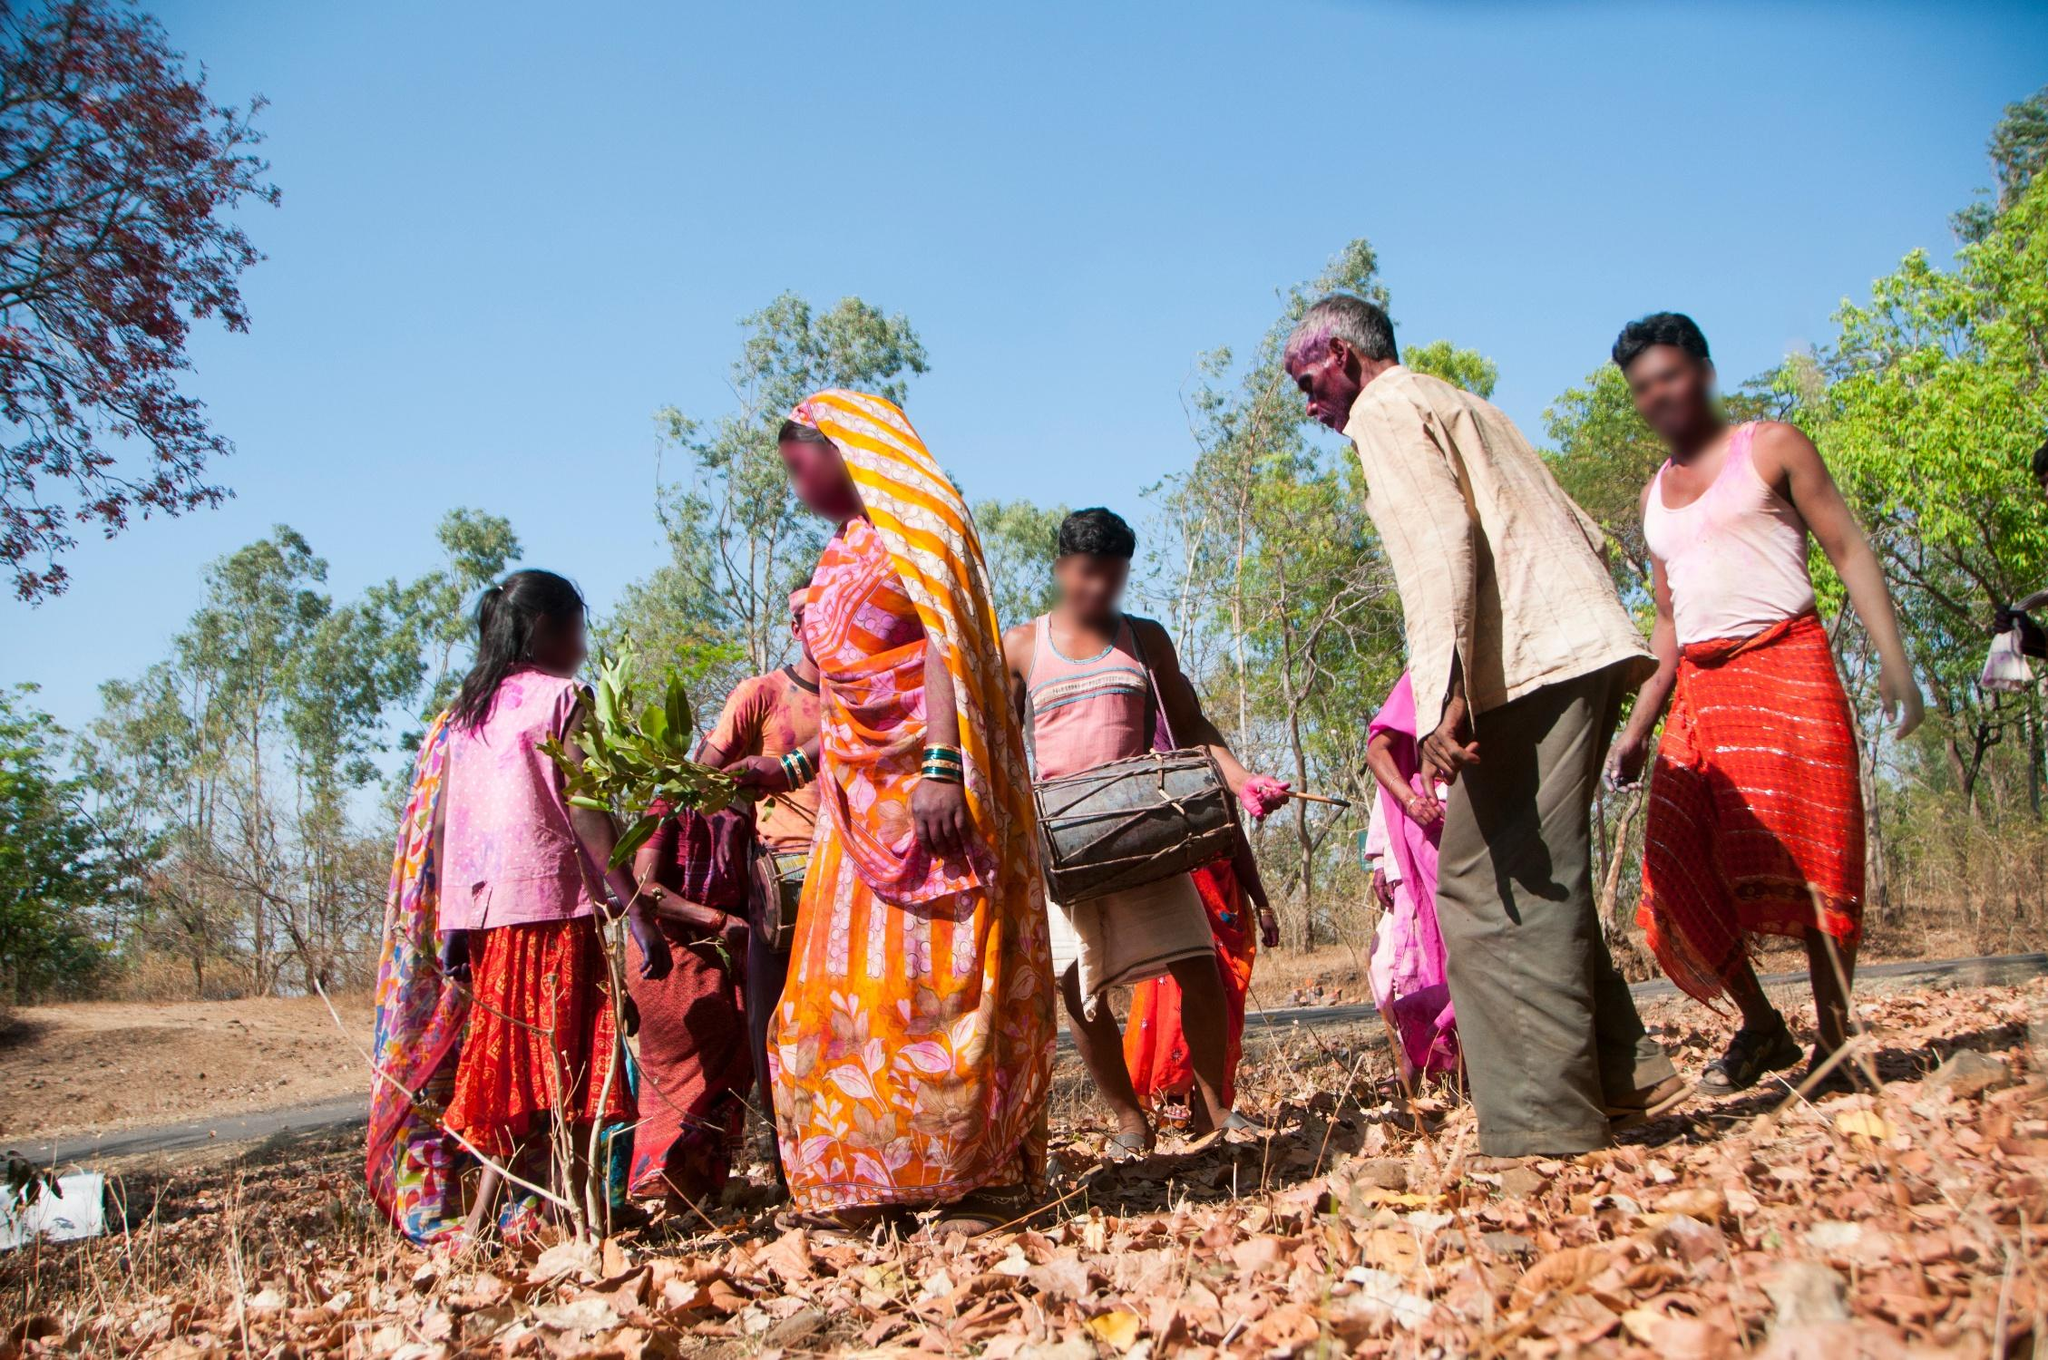What time of the year do you think this could be, and why? Given the dry leaves scattered on the ground and the lush green trees, it's plausible that this image was taken during the late winter or early spring. This is often a time when the old leaves have fallen and new growth is beginning to appear, signifying a transition between seasons. 